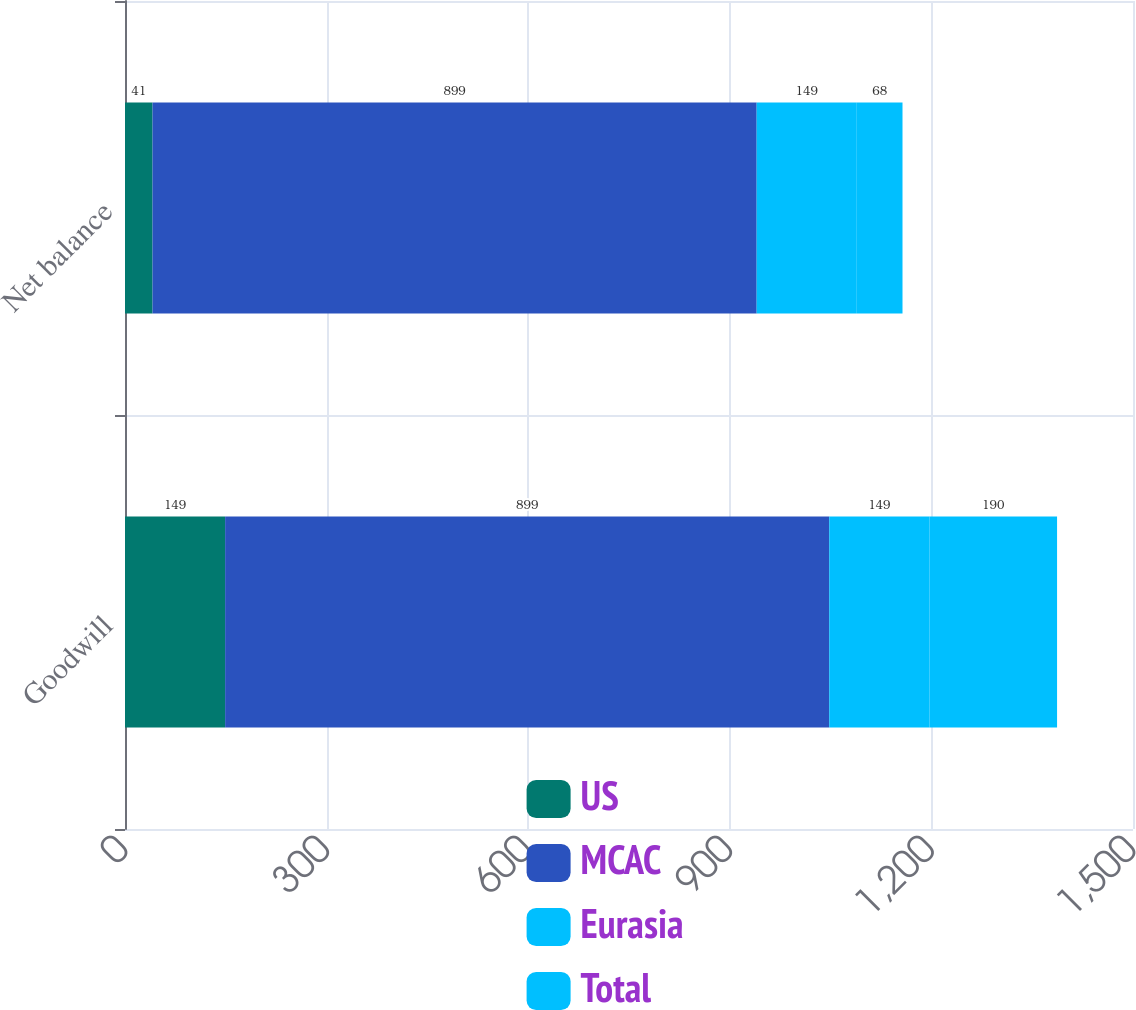<chart> <loc_0><loc_0><loc_500><loc_500><stacked_bar_chart><ecel><fcel>Goodwill<fcel>Net balance<nl><fcel>US<fcel>149<fcel>41<nl><fcel>MCAC<fcel>899<fcel>899<nl><fcel>Eurasia<fcel>149<fcel>149<nl><fcel>Total<fcel>190<fcel>68<nl></chart> 